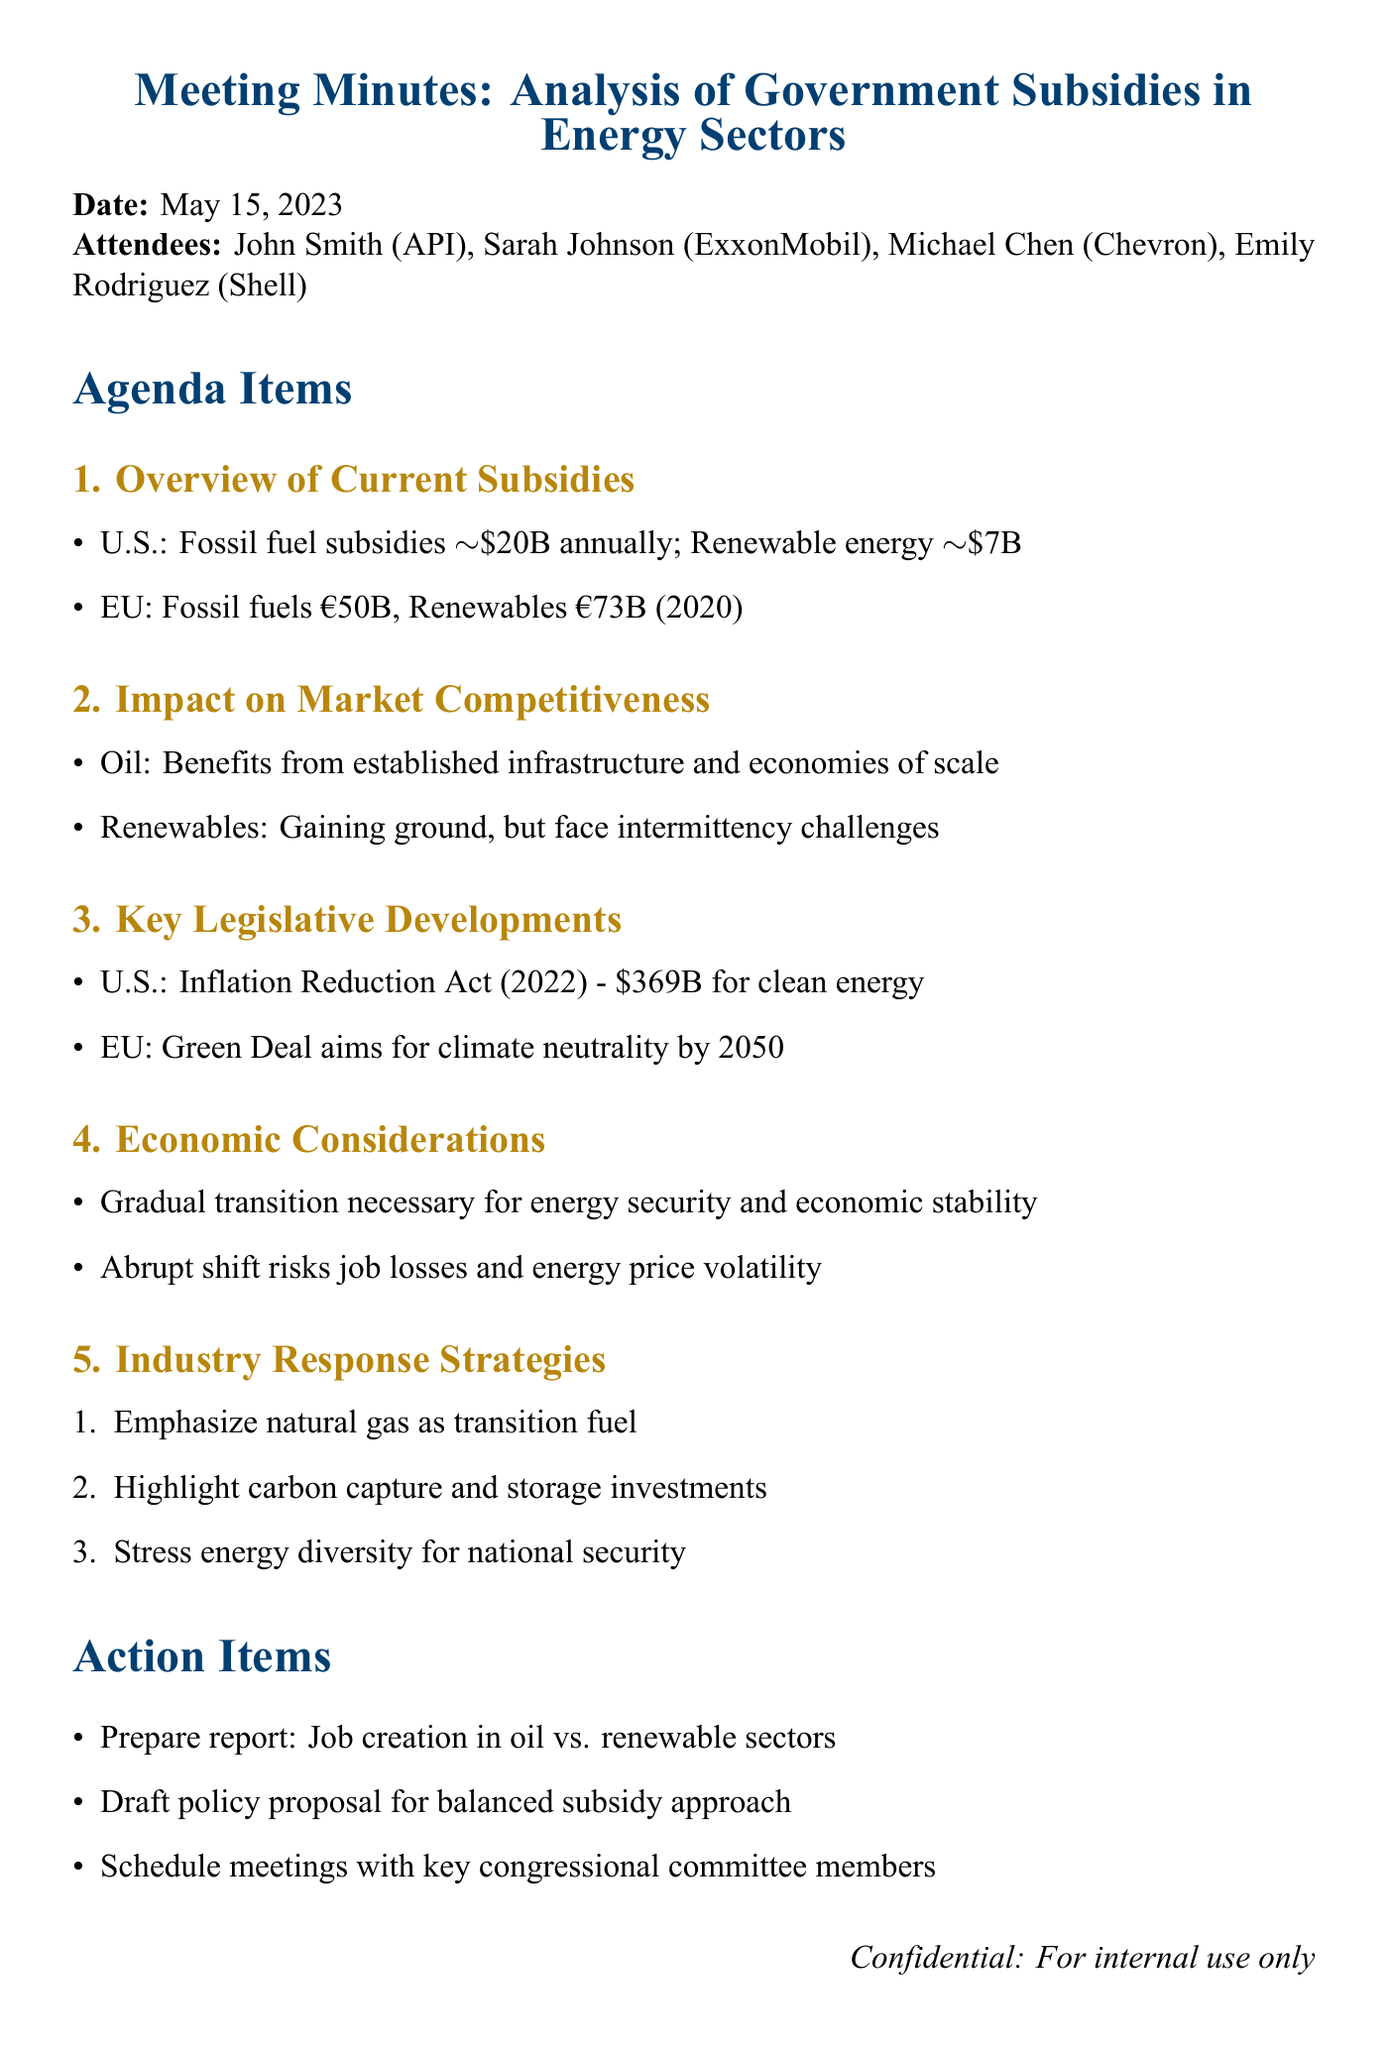What is the date of the meeting? The date of the meeting is stated at the beginning of the document.
Answer: May 15, 2023 How much do U.S. fossil fuel subsidies amount to annually? The document provides a specific financial figure regarding U.S. fossil fuel subsidies in the overview section.
Answer: $20 billion What is the total funding for clean energy initiatives in the Inflation Reduction Act? This information is detailed in the key legislative developments section of the minutes.
Answer: $369 billion What are the two mentioned industries that receive government subsidies? The document explicitly mentions both sectors in the overview section.
Answer: Oil and renewable energy What is a potential risk of an abrupt transition to renewable energy? The economic considerations section outlines the impacts of a rapid transition on job stability.
Answer: Job losses How do oil and renewable energy sectors differ in resource input? The impact on market competitiveness section discusses how each sector capitalizes on different advantages.
Answer: Infrastructure and intermittency What does the EU Green Deal aim for by 2050? The document discusses the goals of the EU Green Deal in the key legislative developments section.
Answer: Climate neutrality What is one strategy mentioned for the industry response? The action items include several strategies used by the industry in response to competition from renewables.
Answer: Emphasize natural gas as a transition fuel 